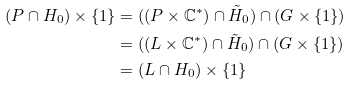<formula> <loc_0><loc_0><loc_500><loc_500>( P \cap H _ { 0 } ) \times \{ 1 \} & = ( ( P \times \mathbb { C } ^ { * } ) \cap \tilde { H } _ { 0 } ) \cap ( G \times \{ 1 \} ) \\ & = ( ( L \times \mathbb { C } ^ { * } ) \cap \tilde { H } _ { 0 } ) \cap ( G \times \{ 1 \} ) \\ & = ( L \cap H _ { 0 } ) \times \{ 1 \}</formula> 